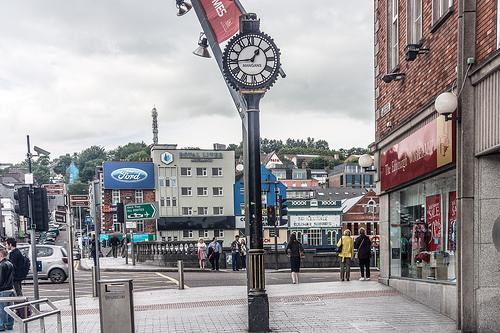Question: how cloudy is it?
Choices:
A. Partly cloudy.
B. Clear.
C. Very cloudy.
D. Overcast.
Answer with the letter. Answer: C Question: what is in the forefront?
Choices:
A. Bovine.
B. Clock.
C. Horse.
D. Dog.
Answer with the letter. Answer: B Question: who is there?
Choices:
A. Neighbors.
B. Children.
C. Passerbys.
D. Elderly.
Answer with the letter. Answer: C Question: where is this scene?
Choices:
A. Sidewalk.
B. Stop Light.
C. Crosswalk.
D. Street corner.
Answer with the letter. Answer: D Question: why is the clock there?
Choices:
A. Decoration.
B. Time Keeper.
C. Tell time.
D. Schedule.
Answer with the letter. Answer: C 